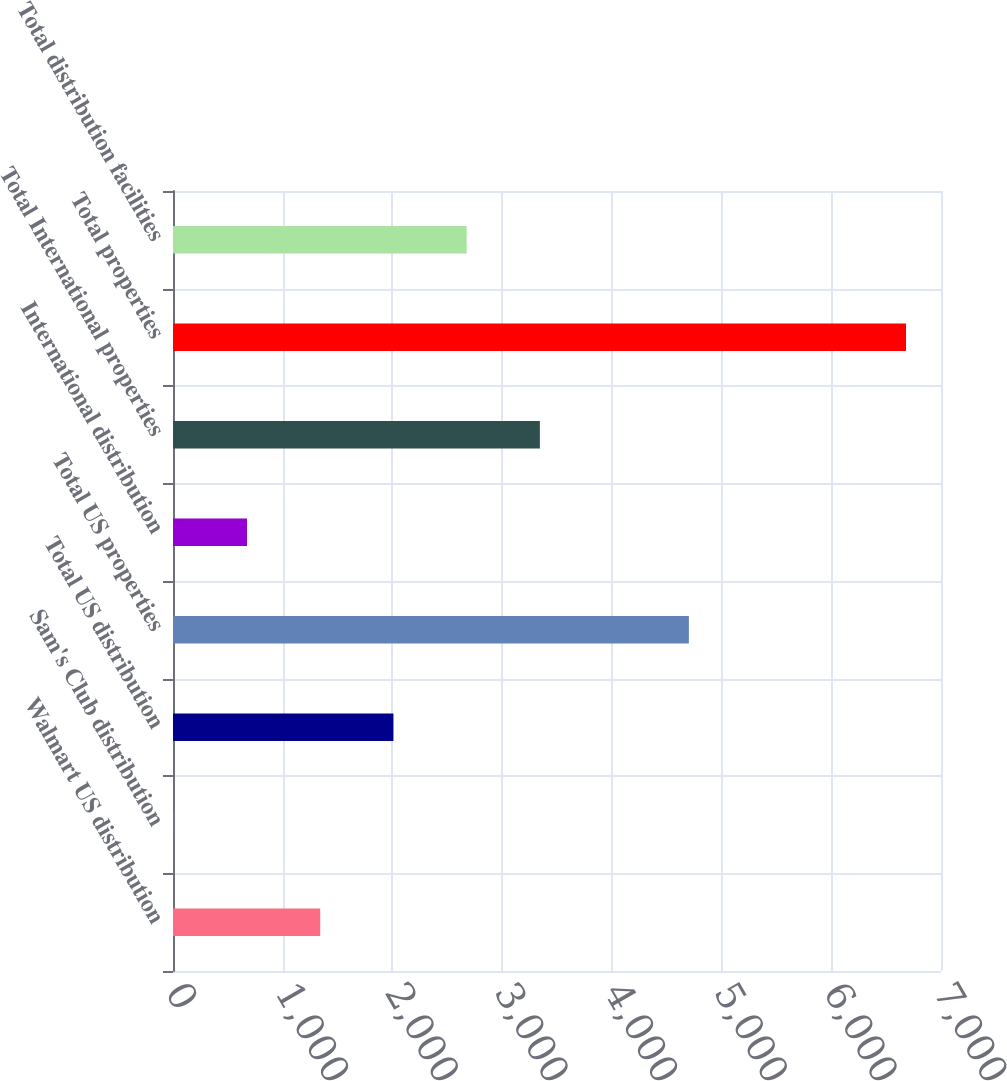Convert chart to OTSL. <chart><loc_0><loc_0><loc_500><loc_500><bar_chart><fcel>Walmart US distribution<fcel>Sam's Club distribution<fcel>Total US distribution<fcel>Total US properties<fcel>International distribution<fcel>Total International properties<fcel>Total properties<fcel>Total distribution facilities<nl><fcel>1341.8<fcel>7<fcel>2009.2<fcel>4702<fcel>674.4<fcel>3344<fcel>6681<fcel>2676.6<nl></chart> 